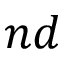<formula> <loc_0><loc_0><loc_500><loc_500>n d</formula> 